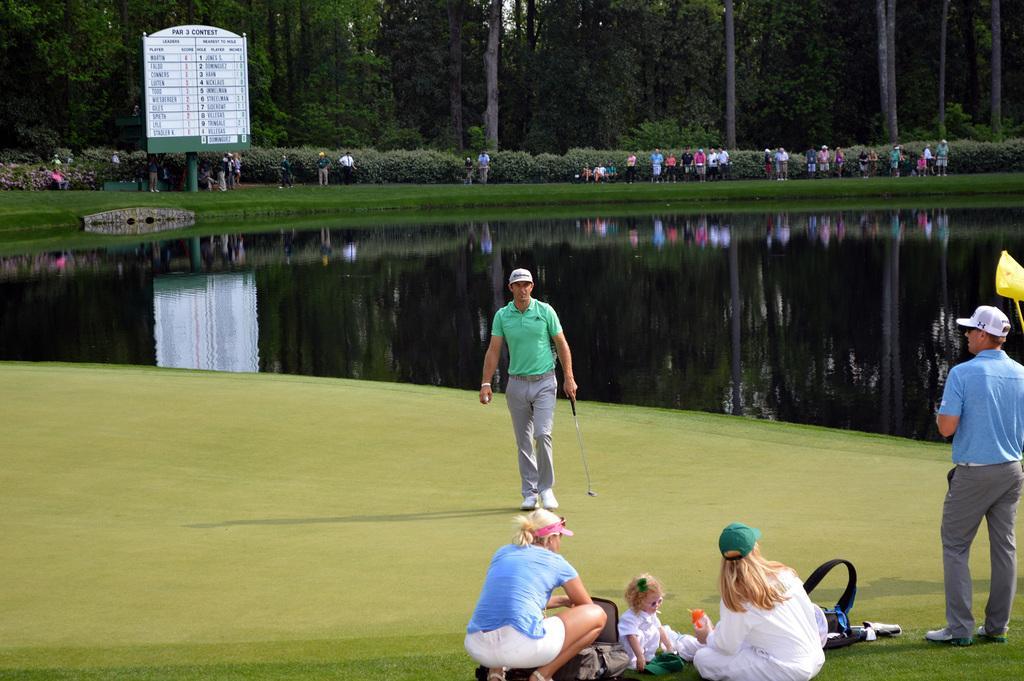Please provide a concise description of this image. In this image we can see the ground, people, plants, trees and also a board with the text. We can also see the water. 